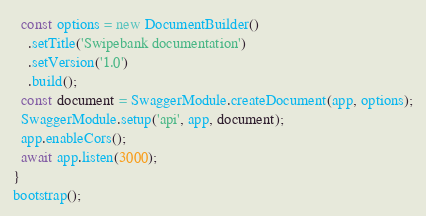<code> <loc_0><loc_0><loc_500><loc_500><_TypeScript_>
  const options = new DocumentBuilder()
    .setTitle('Swipebank documentation')
    .setVersion('1.0')
    .build();
  const document = SwaggerModule.createDocument(app, options);
  SwaggerModule.setup('api', app, document);
  app.enableCors();
  await app.listen(3000);
}
bootstrap();
</code> 